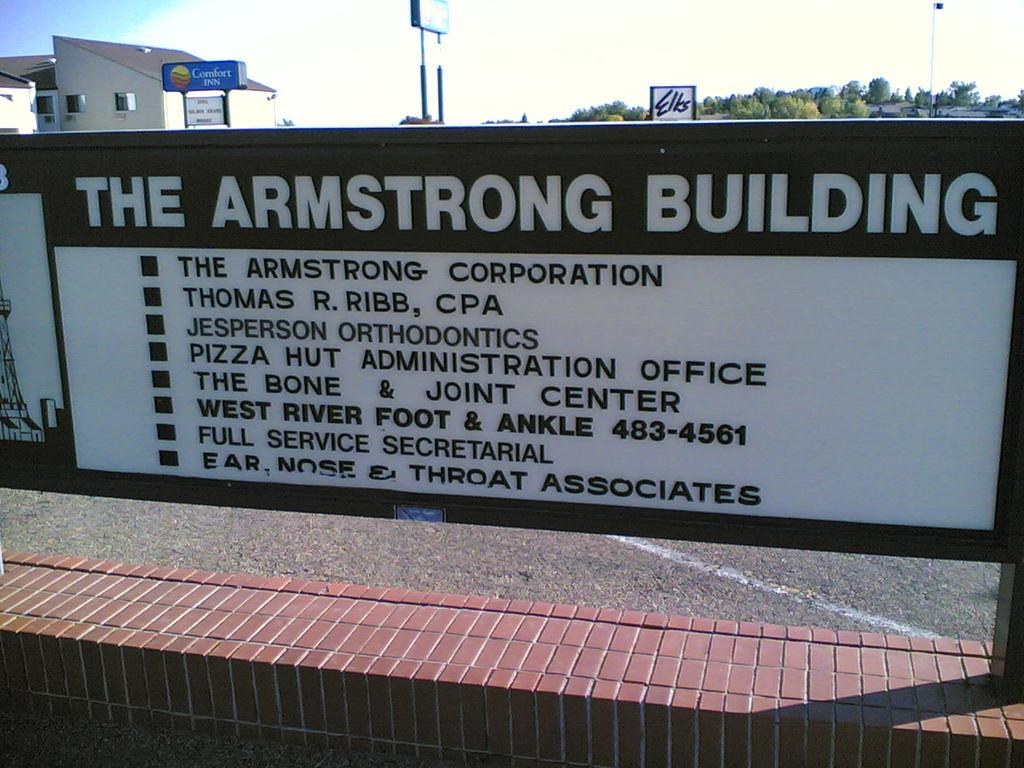Provide a one-sentence caption for the provided image. A sign that says The Armstrong Building is on a brick wall. 